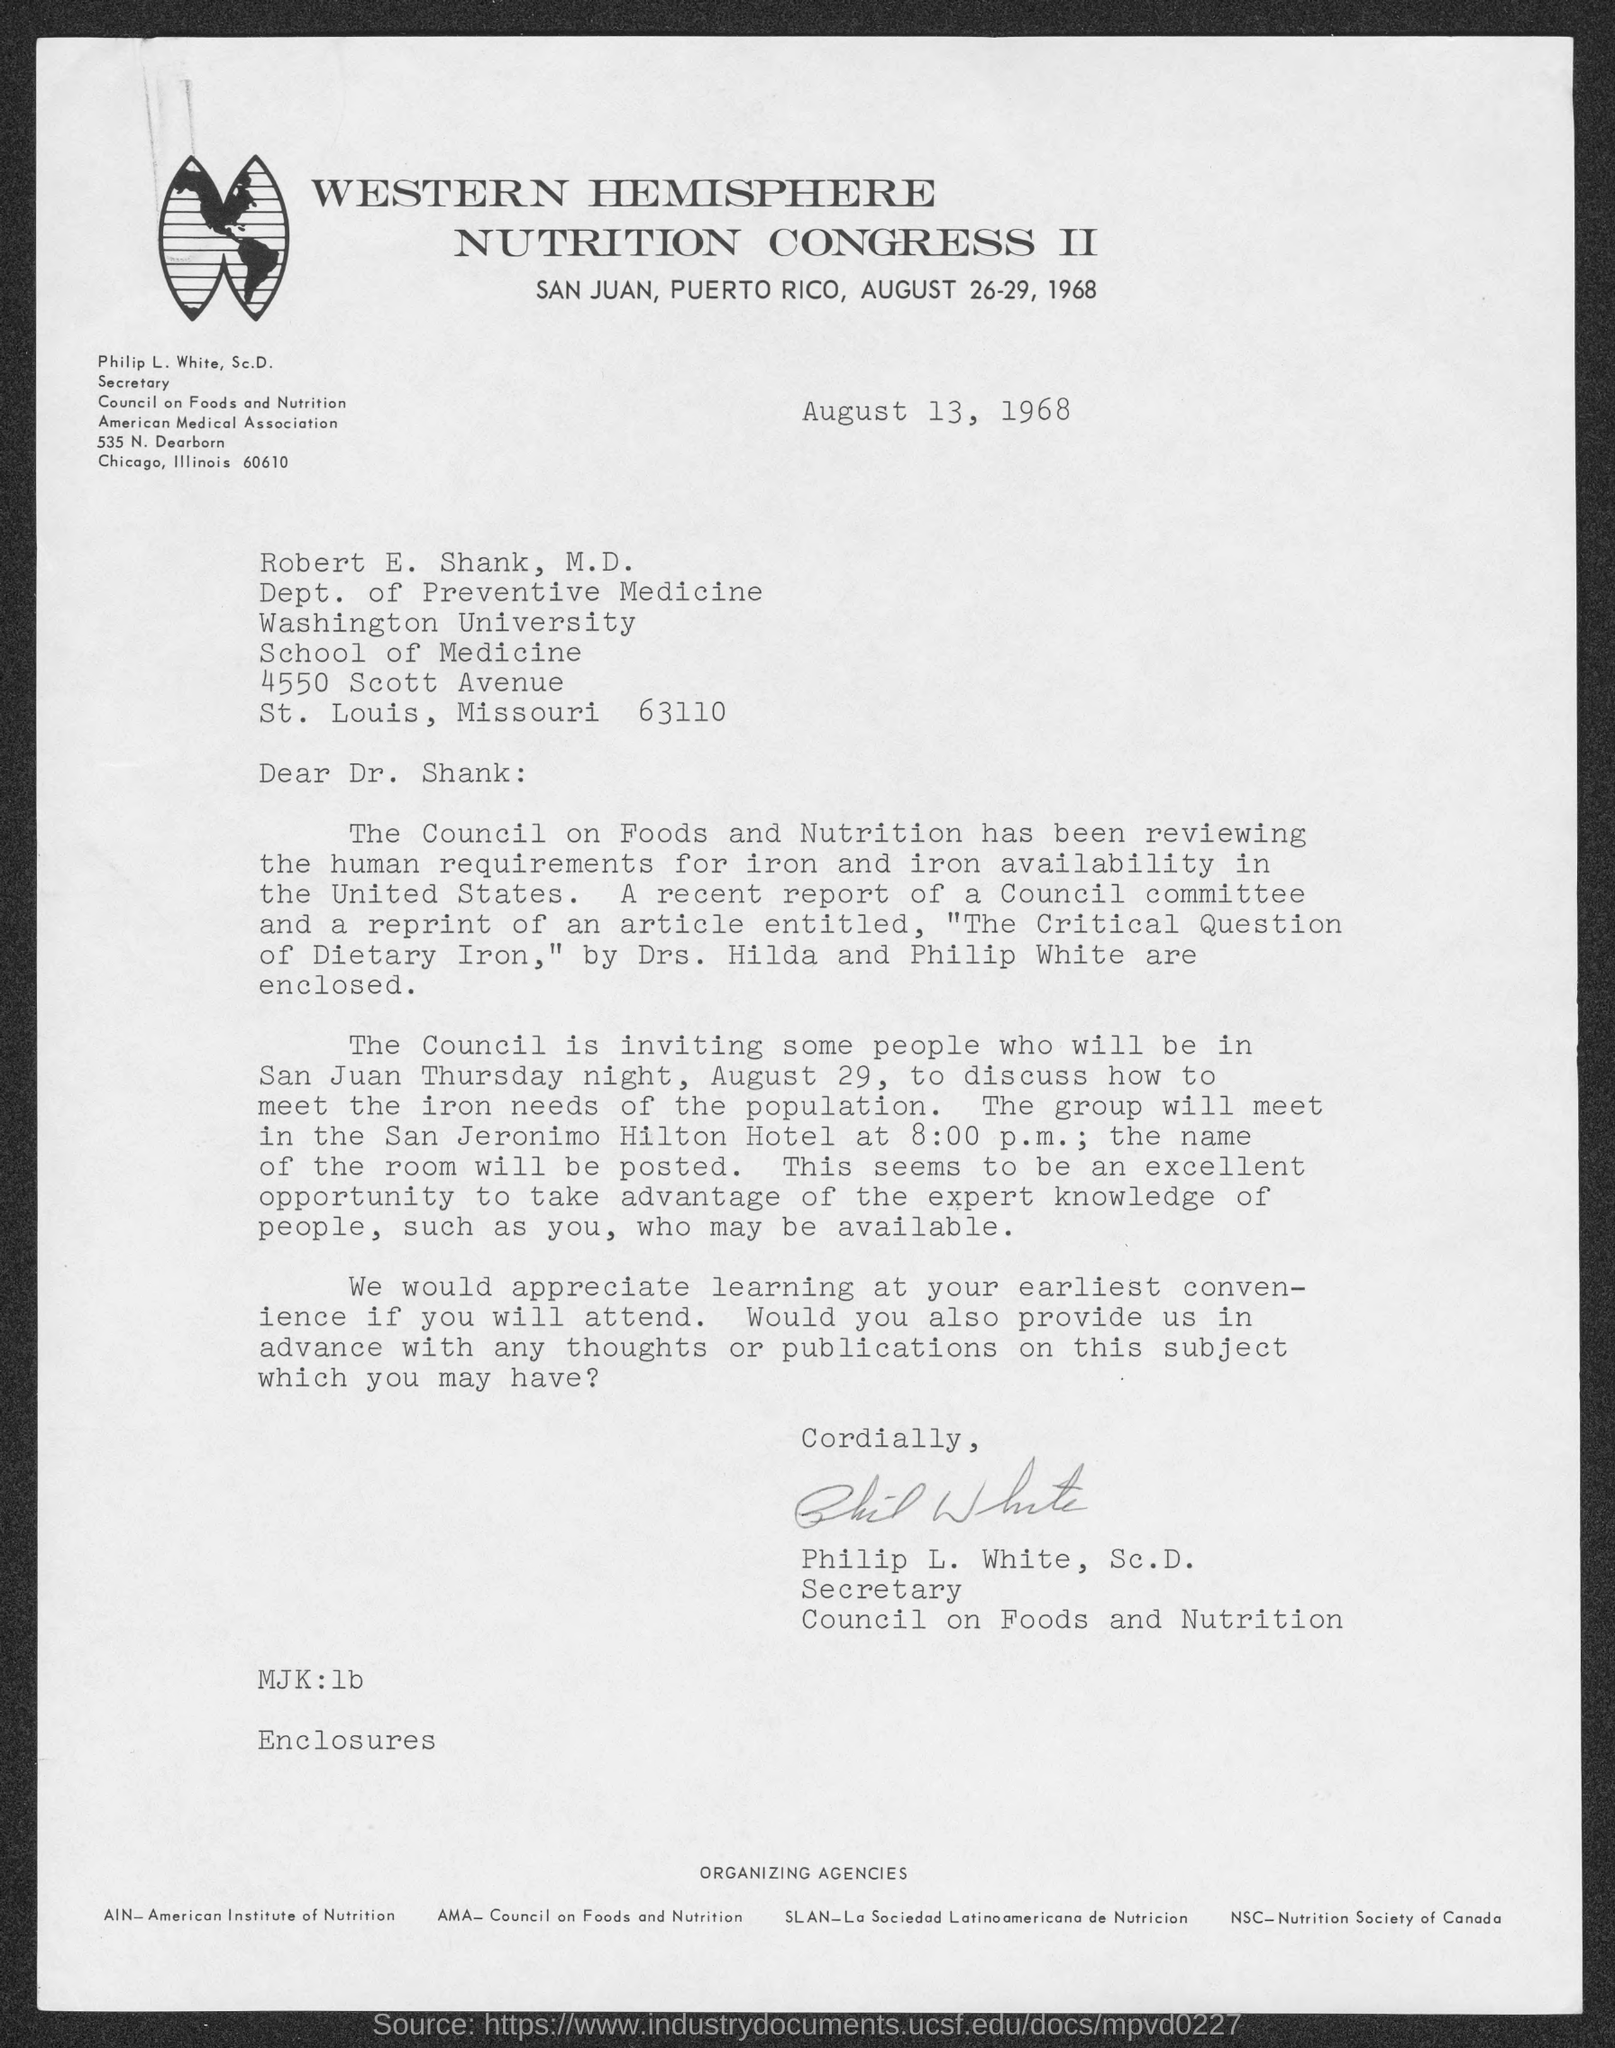Point out several critical features in this image. The letter is addressed to Dr. Shank. The letter was written by Philip L. White. 